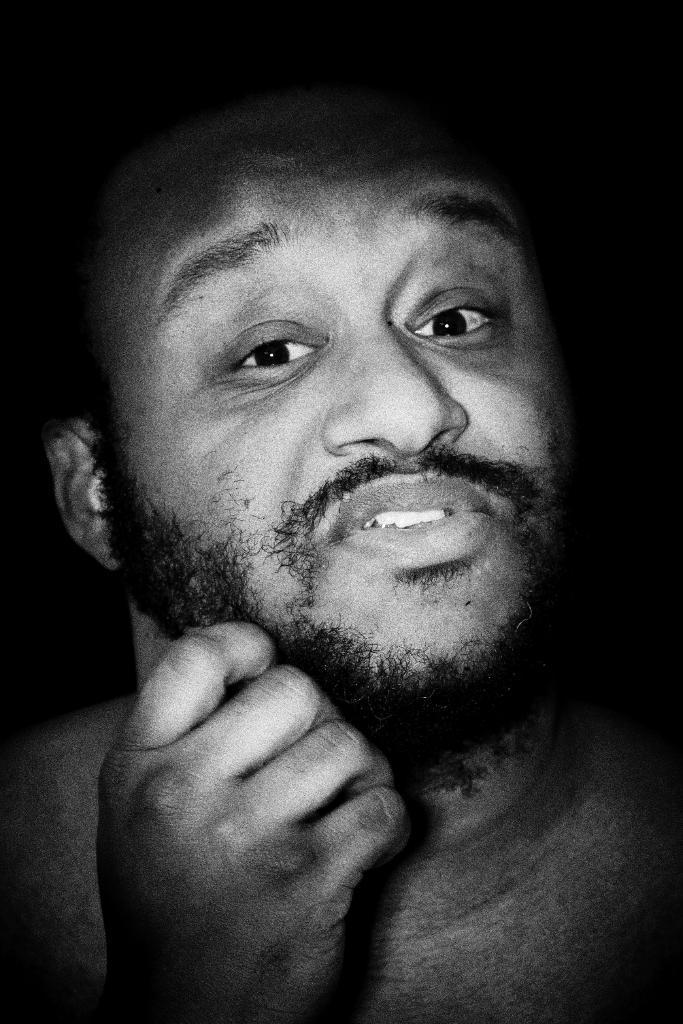Could you give a brief overview of what you see in this image? Here in this picture we can see a man present over a place and we can see facial expression of him. 